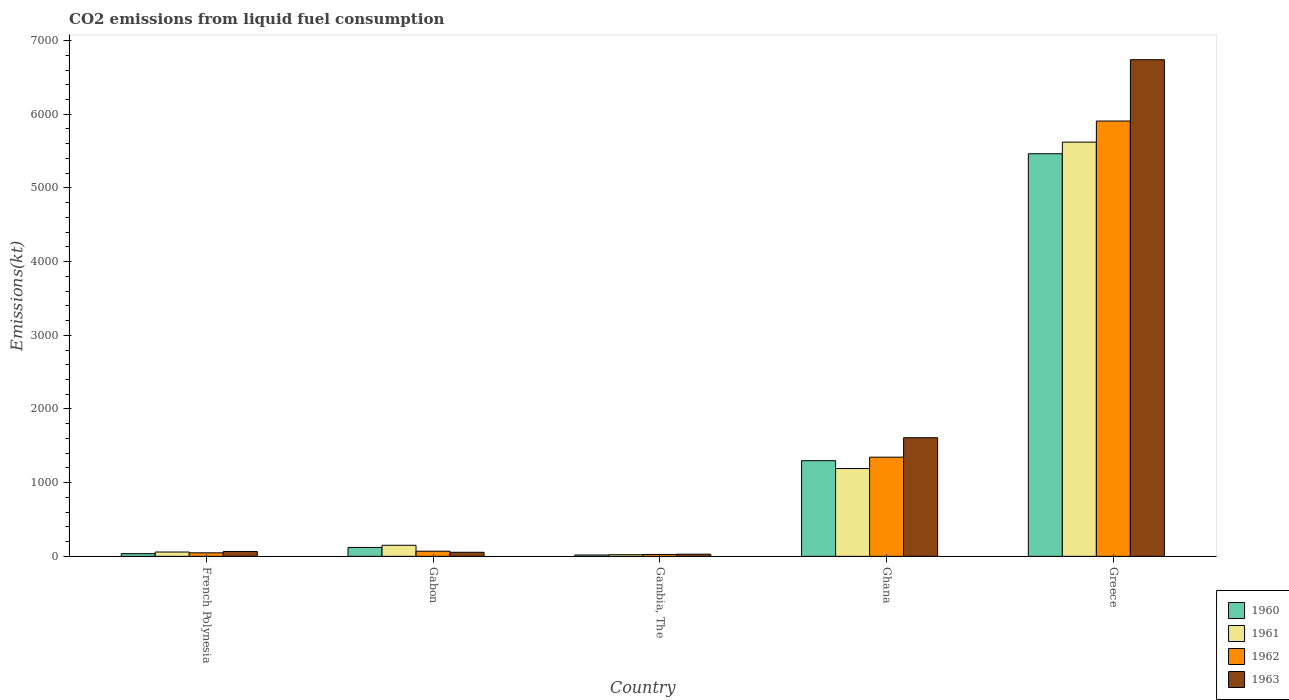How many different coloured bars are there?
Make the answer very short. 4. How many groups of bars are there?
Offer a very short reply. 5. Are the number of bars per tick equal to the number of legend labels?
Provide a short and direct response. Yes. Are the number of bars on each tick of the X-axis equal?
Provide a succinct answer. Yes. How many bars are there on the 3rd tick from the left?
Your response must be concise. 4. What is the label of the 1st group of bars from the left?
Give a very brief answer. French Polynesia. What is the amount of CO2 emitted in 1962 in Greece?
Ensure brevity in your answer.  5907.54. Across all countries, what is the maximum amount of CO2 emitted in 1962?
Offer a terse response. 5907.54. Across all countries, what is the minimum amount of CO2 emitted in 1960?
Keep it short and to the point. 18.34. In which country was the amount of CO2 emitted in 1961 minimum?
Your answer should be very brief. Gambia, The. What is the total amount of CO2 emitted in 1963 in the graph?
Offer a very short reply. 8500.11. What is the difference between the amount of CO2 emitted in 1961 in Gambia, The and that in Ghana?
Give a very brief answer. -1169.77. What is the difference between the amount of CO2 emitted in 1961 in Gabon and the amount of CO2 emitted in 1963 in Greece?
Offer a terse response. -6589.6. What is the average amount of CO2 emitted in 1960 per country?
Make the answer very short. 1387.59. What is the difference between the amount of CO2 emitted of/in 1963 and amount of CO2 emitted of/in 1961 in French Polynesia?
Keep it short and to the point. 7.33. What is the ratio of the amount of CO2 emitted in 1962 in French Polynesia to that in Gambia, The?
Provide a short and direct response. 1.86. Is the amount of CO2 emitted in 1961 in Gambia, The less than that in Ghana?
Your response must be concise. Yes. What is the difference between the highest and the second highest amount of CO2 emitted in 1960?
Ensure brevity in your answer.  -1177.11. What is the difference between the highest and the lowest amount of CO2 emitted in 1961?
Your response must be concise. 5599.51. What does the 3rd bar from the left in Gambia, The represents?
Offer a very short reply. 1962. How many countries are there in the graph?
Offer a very short reply. 5. Does the graph contain any zero values?
Provide a short and direct response. No. Where does the legend appear in the graph?
Keep it short and to the point. Bottom right. How are the legend labels stacked?
Keep it short and to the point. Vertical. What is the title of the graph?
Provide a short and direct response. CO2 emissions from liquid fuel consumption. Does "2011" appear as one of the legend labels in the graph?
Ensure brevity in your answer.  No. What is the label or title of the Y-axis?
Keep it short and to the point. Emissions(kt). What is the Emissions(kt) in 1960 in French Polynesia?
Offer a terse response. 36.67. What is the Emissions(kt) of 1961 in French Polynesia?
Provide a succinct answer. 58.67. What is the Emissions(kt) of 1962 in French Polynesia?
Your response must be concise. 47.67. What is the Emissions(kt) in 1963 in French Polynesia?
Your answer should be very brief. 66.01. What is the Emissions(kt) in 1960 in Gabon?
Give a very brief answer. 121.01. What is the Emissions(kt) of 1961 in Gabon?
Keep it short and to the point. 150.35. What is the Emissions(kt) of 1962 in Gabon?
Provide a succinct answer. 69.67. What is the Emissions(kt) in 1963 in Gabon?
Your answer should be compact. 55.01. What is the Emissions(kt) in 1960 in Gambia, The?
Ensure brevity in your answer.  18.34. What is the Emissions(kt) of 1961 in Gambia, The?
Your response must be concise. 22. What is the Emissions(kt) of 1962 in Gambia, The?
Give a very brief answer. 25.67. What is the Emissions(kt) in 1963 in Gambia, The?
Provide a short and direct response. 29.34. What is the Emissions(kt) in 1960 in Ghana?
Provide a succinct answer. 1298.12. What is the Emissions(kt) in 1961 in Ghana?
Keep it short and to the point. 1191.78. What is the Emissions(kt) of 1962 in Ghana?
Keep it short and to the point. 1345.79. What is the Emissions(kt) of 1963 in Ghana?
Your response must be concise. 1609.81. What is the Emissions(kt) in 1960 in Greece?
Ensure brevity in your answer.  5463.83. What is the Emissions(kt) in 1961 in Greece?
Your answer should be compact. 5621.51. What is the Emissions(kt) in 1962 in Greece?
Ensure brevity in your answer.  5907.54. What is the Emissions(kt) of 1963 in Greece?
Provide a succinct answer. 6739.95. Across all countries, what is the maximum Emissions(kt) in 1960?
Your response must be concise. 5463.83. Across all countries, what is the maximum Emissions(kt) of 1961?
Your answer should be very brief. 5621.51. Across all countries, what is the maximum Emissions(kt) of 1962?
Offer a very short reply. 5907.54. Across all countries, what is the maximum Emissions(kt) of 1963?
Provide a short and direct response. 6739.95. Across all countries, what is the minimum Emissions(kt) of 1960?
Provide a short and direct response. 18.34. Across all countries, what is the minimum Emissions(kt) of 1961?
Give a very brief answer. 22. Across all countries, what is the minimum Emissions(kt) of 1962?
Your response must be concise. 25.67. Across all countries, what is the minimum Emissions(kt) in 1963?
Ensure brevity in your answer.  29.34. What is the total Emissions(kt) in 1960 in the graph?
Your answer should be compact. 6937.96. What is the total Emissions(kt) in 1961 in the graph?
Provide a short and direct response. 7044.31. What is the total Emissions(kt) in 1962 in the graph?
Provide a short and direct response. 7396.34. What is the total Emissions(kt) of 1963 in the graph?
Keep it short and to the point. 8500.11. What is the difference between the Emissions(kt) of 1960 in French Polynesia and that in Gabon?
Make the answer very short. -84.34. What is the difference between the Emissions(kt) of 1961 in French Polynesia and that in Gabon?
Keep it short and to the point. -91.67. What is the difference between the Emissions(kt) of 1962 in French Polynesia and that in Gabon?
Offer a terse response. -22. What is the difference between the Emissions(kt) of 1963 in French Polynesia and that in Gabon?
Offer a very short reply. 11. What is the difference between the Emissions(kt) of 1960 in French Polynesia and that in Gambia, The?
Provide a short and direct response. 18.34. What is the difference between the Emissions(kt) in 1961 in French Polynesia and that in Gambia, The?
Make the answer very short. 36.67. What is the difference between the Emissions(kt) of 1962 in French Polynesia and that in Gambia, The?
Your response must be concise. 22. What is the difference between the Emissions(kt) in 1963 in French Polynesia and that in Gambia, The?
Keep it short and to the point. 36.67. What is the difference between the Emissions(kt) of 1960 in French Polynesia and that in Ghana?
Give a very brief answer. -1261.45. What is the difference between the Emissions(kt) in 1961 in French Polynesia and that in Ghana?
Provide a short and direct response. -1133.1. What is the difference between the Emissions(kt) in 1962 in French Polynesia and that in Ghana?
Your response must be concise. -1298.12. What is the difference between the Emissions(kt) in 1963 in French Polynesia and that in Ghana?
Provide a short and direct response. -1543.81. What is the difference between the Emissions(kt) of 1960 in French Polynesia and that in Greece?
Keep it short and to the point. -5427.16. What is the difference between the Emissions(kt) in 1961 in French Polynesia and that in Greece?
Make the answer very short. -5562.84. What is the difference between the Emissions(kt) of 1962 in French Polynesia and that in Greece?
Your answer should be compact. -5859.87. What is the difference between the Emissions(kt) of 1963 in French Polynesia and that in Greece?
Give a very brief answer. -6673.94. What is the difference between the Emissions(kt) of 1960 in Gabon and that in Gambia, The?
Provide a short and direct response. 102.68. What is the difference between the Emissions(kt) of 1961 in Gabon and that in Gambia, The?
Keep it short and to the point. 128.34. What is the difference between the Emissions(kt) of 1962 in Gabon and that in Gambia, The?
Ensure brevity in your answer.  44. What is the difference between the Emissions(kt) in 1963 in Gabon and that in Gambia, The?
Provide a succinct answer. 25.67. What is the difference between the Emissions(kt) of 1960 in Gabon and that in Ghana?
Offer a terse response. -1177.11. What is the difference between the Emissions(kt) of 1961 in Gabon and that in Ghana?
Keep it short and to the point. -1041.43. What is the difference between the Emissions(kt) of 1962 in Gabon and that in Ghana?
Provide a succinct answer. -1276.12. What is the difference between the Emissions(kt) of 1963 in Gabon and that in Ghana?
Offer a very short reply. -1554.81. What is the difference between the Emissions(kt) in 1960 in Gabon and that in Greece?
Offer a terse response. -5342.82. What is the difference between the Emissions(kt) of 1961 in Gabon and that in Greece?
Offer a very short reply. -5471.16. What is the difference between the Emissions(kt) of 1962 in Gabon and that in Greece?
Provide a succinct answer. -5837.86. What is the difference between the Emissions(kt) of 1963 in Gabon and that in Greece?
Ensure brevity in your answer.  -6684.94. What is the difference between the Emissions(kt) in 1960 in Gambia, The and that in Ghana?
Keep it short and to the point. -1279.78. What is the difference between the Emissions(kt) of 1961 in Gambia, The and that in Ghana?
Provide a short and direct response. -1169.77. What is the difference between the Emissions(kt) in 1962 in Gambia, The and that in Ghana?
Give a very brief answer. -1320.12. What is the difference between the Emissions(kt) of 1963 in Gambia, The and that in Ghana?
Offer a very short reply. -1580.48. What is the difference between the Emissions(kt) in 1960 in Gambia, The and that in Greece?
Your response must be concise. -5445.49. What is the difference between the Emissions(kt) of 1961 in Gambia, The and that in Greece?
Your answer should be compact. -5599.51. What is the difference between the Emissions(kt) of 1962 in Gambia, The and that in Greece?
Your answer should be very brief. -5881.87. What is the difference between the Emissions(kt) of 1963 in Gambia, The and that in Greece?
Offer a terse response. -6710.61. What is the difference between the Emissions(kt) of 1960 in Ghana and that in Greece?
Keep it short and to the point. -4165.71. What is the difference between the Emissions(kt) in 1961 in Ghana and that in Greece?
Your answer should be very brief. -4429.74. What is the difference between the Emissions(kt) of 1962 in Ghana and that in Greece?
Provide a succinct answer. -4561.75. What is the difference between the Emissions(kt) in 1963 in Ghana and that in Greece?
Provide a succinct answer. -5130.13. What is the difference between the Emissions(kt) in 1960 in French Polynesia and the Emissions(kt) in 1961 in Gabon?
Make the answer very short. -113.68. What is the difference between the Emissions(kt) in 1960 in French Polynesia and the Emissions(kt) in 1962 in Gabon?
Keep it short and to the point. -33. What is the difference between the Emissions(kt) of 1960 in French Polynesia and the Emissions(kt) of 1963 in Gabon?
Offer a very short reply. -18.34. What is the difference between the Emissions(kt) in 1961 in French Polynesia and the Emissions(kt) in 1962 in Gabon?
Give a very brief answer. -11. What is the difference between the Emissions(kt) of 1961 in French Polynesia and the Emissions(kt) of 1963 in Gabon?
Your response must be concise. 3.67. What is the difference between the Emissions(kt) in 1962 in French Polynesia and the Emissions(kt) in 1963 in Gabon?
Offer a terse response. -7.33. What is the difference between the Emissions(kt) of 1960 in French Polynesia and the Emissions(kt) of 1961 in Gambia, The?
Ensure brevity in your answer.  14.67. What is the difference between the Emissions(kt) in 1960 in French Polynesia and the Emissions(kt) in 1962 in Gambia, The?
Your response must be concise. 11. What is the difference between the Emissions(kt) of 1960 in French Polynesia and the Emissions(kt) of 1963 in Gambia, The?
Give a very brief answer. 7.33. What is the difference between the Emissions(kt) of 1961 in French Polynesia and the Emissions(kt) of 1962 in Gambia, The?
Keep it short and to the point. 33. What is the difference between the Emissions(kt) in 1961 in French Polynesia and the Emissions(kt) in 1963 in Gambia, The?
Keep it short and to the point. 29.34. What is the difference between the Emissions(kt) in 1962 in French Polynesia and the Emissions(kt) in 1963 in Gambia, The?
Ensure brevity in your answer.  18.34. What is the difference between the Emissions(kt) of 1960 in French Polynesia and the Emissions(kt) of 1961 in Ghana?
Give a very brief answer. -1155.11. What is the difference between the Emissions(kt) in 1960 in French Polynesia and the Emissions(kt) in 1962 in Ghana?
Your answer should be very brief. -1309.12. What is the difference between the Emissions(kt) of 1960 in French Polynesia and the Emissions(kt) of 1963 in Ghana?
Offer a very short reply. -1573.14. What is the difference between the Emissions(kt) in 1961 in French Polynesia and the Emissions(kt) in 1962 in Ghana?
Your response must be concise. -1287.12. What is the difference between the Emissions(kt) in 1961 in French Polynesia and the Emissions(kt) in 1963 in Ghana?
Offer a terse response. -1551.14. What is the difference between the Emissions(kt) of 1962 in French Polynesia and the Emissions(kt) of 1963 in Ghana?
Your answer should be very brief. -1562.14. What is the difference between the Emissions(kt) of 1960 in French Polynesia and the Emissions(kt) of 1961 in Greece?
Offer a terse response. -5584.84. What is the difference between the Emissions(kt) of 1960 in French Polynesia and the Emissions(kt) of 1962 in Greece?
Ensure brevity in your answer.  -5870.87. What is the difference between the Emissions(kt) in 1960 in French Polynesia and the Emissions(kt) in 1963 in Greece?
Make the answer very short. -6703.28. What is the difference between the Emissions(kt) of 1961 in French Polynesia and the Emissions(kt) of 1962 in Greece?
Provide a short and direct response. -5848.86. What is the difference between the Emissions(kt) in 1961 in French Polynesia and the Emissions(kt) in 1963 in Greece?
Keep it short and to the point. -6681.27. What is the difference between the Emissions(kt) in 1962 in French Polynesia and the Emissions(kt) in 1963 in Greece?
Make the answer very short. -6692.27. What is the difference between the Emissions(kt) in 1960 in Gabon and the Emissions(kt) in 1961 in Gambia, The?
Give a very brief answer. 99.01. What is the difference between the Emissions(kt) in 1960 in Gabon and the Emissions(kt) in 1962 in Gambia, The?
Your answer should be very brief. 95.34. What is the difference between the Emissions(kt) in 1960 in Gabon and the Emissions(kt) in 1963 in Gambia, The?
Your answer should be compact. 91.67. What is the difference between the Emissions(kt) in 1961 in Gabon and the Emissions(kt) in 1962 in Gambia, The?
Offer a terse response. 124.68. What is the difference between the Emissions(kt) in 1961 in Gabon and the Emissions(kt) in 1963 in Gambia, The?
Your answer should be very brief. 121.01. What is the difference between the Emissions(kt) of 1962 in Gabon and the Emissions(kt) of 1963 in Gambia, The?
Offer a very short reply. 40.34. What is the difference between the Emissions(kt) in 1960 in Gabon and the Emissions(kt) in 1961 in Ghana?
Offer a very short reply. -1070.76. What is the difference between the Emissions(kt) in 1960 in Gabon and the Emissions(kt) in 1962 in Ghana?
Offer a terse response. -1224.78. What is the difference between the Emissions(kt) in 1960 in Gabon and the Emissions(kt) in 1963 in Ghana?
Your answer should be compact. -1488.8. What is the difference between the Emissions(kt) of 1961 in Gabon and the Emissions(kt) of 1962 in Ghana?
Provide a succinct answer. -1195.44. What is the difference between the Emissions(kt) of 1961 in Gabon and the Emissions(kt) of 1963 in Ghana?
Make the answer very short. -1459.47. What is the difference between the Emissions(kt) in 1962 in Gabon and the Emissions(kt) in 1963 in Ghana?
Provide a short and direct response. -1540.14. What is the difference between the Emissions(kt) in 1960 in Gabon and the Emissions(kt) in 1961 in Greece?
Offer a terse response. -5500.5. What is the difference between the Emissions(kt) of 1960 in Gabon and the Emissions(kt) of 1962 in Greece?
Provide a succinct answer. -5786.53. What is the difference between the Emissions(kt) of 1960 in Gabon and the Emissions(kt) of 1963 in Greece?
Keep it short and to the point. -6618.94. What is the difference between the Emissions(kt) in 1961 in Gabon and the Emissions(kt) in 1962 in Greece?
Your answer should be very brief. -5757.19. What is the difference between the Emissions(kt) in 1961 in Gabon and the Emissions(kt) in 1963 in Greece?
Keep it short and to the point. -6589.6. What is the difference between the Emissions(kt) of 1962 in Gabon and the Emissions(kt) of 1963 in Greece?
Your response must be concise. -6670.27. What is the difference between the Emissions(kt) of 1960 in Gambia, The and the Emissions(kt) of 1961 in Ghana?
Give a very brief answer. -1173.44. What is the difference between the Emissions(kt) in 1960 in Gambia, The and the Emissions(kt) in 1962 in Ghana?
Offer a terse response. -1327.45. What is the difference between the Emissions(kt) of 1960 in Gambia, The and the Emissions(kt) of 1963 in Ghana?
Make the answer very short. -1591.48. What is the difference between the Emissions(kt) in 1961 in Gambia, The and the Emissions(kt) in 1962 in Ghana?
Give a very brief answer. -1323.79. What is the difference between the Emissions(kt) of 1961 in Gambia, The and the Emissions(kt) of 1963 in Ghana?
Provide a short and direct response. -1587.81. What is the difference between the Emissions(kt) of 1962 in Gambia, The and the Emissions(kt) of 1963 in Ghana?
Provide a succinct answer. -1584.14. What is the difference between the Emissions(kt) in 1960 in Gambia, The and the Emissions(kt) in 1961 in Greece?
Offer a terse response. -5603.18. What is the difference between the Emissions(kt) of 1960 in Gambia, The and the Emissions(kt) of 1962 in Greece?
Your answer should be very brief. -5889.2. What is the difference between the Emissions(kt) in 1960 in Gambia, The and the Emissions(kt) in 1963 in Greece?
Ensure brevity in your answer.  -6721.61. What is the difference between the Emissions(kt) in 1961 in Gambia, The and the Emissions(kt) in 1962 in Greece?
Your answer should be very brief. -5885.53. What is the difference between the Emissions(kt) of 1961 in Gambia, The and the Emissions(kt) of 1963 in Greece?
Provide a succinct answer. -6717.94. What is the difference between the Emissions(kt) of 1962 in Gambia, The and the Emissions(kt) of 1963 in Greece?
Keep it short and to the point. -6714.28. What is the difference between the Emissions(kt) in 1960 in Ghana and the Emissions(kt) in 1961 in Greece?
Provide a short and direct response. -4323.39. What is the difference between the Emissions(kt) in 1960 in Ghana and the Emissions(kt) in 1962 in Greece?
Your response must be concise. -4609.42. What is the difference between the Emissions(kt) of 1960 in Ghana and the Emissions(kt) of 1963 in Greece?
Provide a succinct answer. -5441.83. What is the difference between the Emissions(kt) in 1961 in Ghana and the Emissions(kt) in 1962 in Greece?
Provide a succinct answer. -4715.76. What is the difference between the Emissions(kt) of 1961 in Ghana and the Emissions(kt) of 1963 in Greece?
Offer a very short reply. -5548.17. What is the difference between the Emissions(kt) of 1962 in Ghana and the Emissions(kt) of 1963 in Greece?
Give a very brief answer. -5394.16. What is the average Emissions(kt) in 1960 per country?
Your response must be concise. 1387.59. What is the average Emissions(kt) in 1961 per country?
Keep it short and to the point. 1408.86. What is the average Emissions(kt) of 1962 per country?
Your answer should be compact. 1479.27. What is the average Emissions(kt) of 1963 per country?
Offer a very short reply. 1700.02. What is the difference between the Emissions(kt) in 1960 and Emissions(kt) in 1961 in French Polynesia?
Your response must be concise. -22. What is the difference between the Emissions(kt) in 1960 and Emissions(kt) in 1962 in French Polynesia?
Your response must be concise. -11. What is the difference between the Emissions(kt) in 1960 and Emissions(kt) in 1963 in French Polynesia?
Your answer should be very brief. -29.34. What is the difference between the Emissions(kt) in 1961 and Emissions(kt) in 1962 in French Polynesia?
Offer a very short reply. 11. What is the difference between the Emissions(kt) in 1961 and Emissions(kt) in 1963 in French Polynesia?
Give a very brief answer. -7.33. What is the difference between the Emissions(kt) of 1962 and Emissions(kt) of 1963 in French Polynesia?
Your response must be concise. -18.34. What is the difference between the Emissions(kt) of 1960 and Emissions(kt) of 1961 in Gabon?
Provide a succinct answer. -29.34. What is the difference between the Emissions(kt) in 1960 and Emissions(kt) in 1962 in Gabon?
Your answer should be very brief. 51.34. What is the difference between the Emissions(kt) of 1960 and Emissions(kt) of 1963 in Gabon?
Offer a terse response. 66.01. What is the difference between the Emissions(kt) of 1961 and Emissions(kt) of 1962 in Gabon?
Keep it short and to the point. 80.67. What is the difference between the Emissions(kt) of 1961 and Emissions(kt) of 1963 in Gabon?
Your answer should be very brief. 95.34. What is the difference between the Emissions(kt) in 1962 and Emissions(kt) in 1963 in Gabon?
Ensure brevity in your answer.  14.67. What is the difference between the Emissions(kt) of 1960 and Emissions(kt) of 1961 in Gambia, The?
Your response must be concise. -3.67. What is the difference between the Emissions(kt) in 1960 and Emissions(kt) in 1962 in Gambia, The?
Provide a succinct answer. -7.33. What is the difference between the Emissions(kt) in 1960 and Emissions(kt) in 1963 in Gambia, The?
Keep it short and to the point. -11. What is the difference between the Emissions(kt) in 1961 and Emissions(kt) in 1962 in Gambia, The?
Ensure brevity in your answer.  -3.67. What is the difference between the Emissions(kt) in 1961 and Emissions(kt) in 1963 in Gambia, The?
Offer a very short reply. -7.33. What is the difference between the Emissions(kt) of 1962 and Emissions(kt) of 1963 in Gambia, The?
Ensure brevity in your answer.  -3.67. What is the difference between the Emissions(kt) of 1960 and Emissions(kt) of 1961 in Ghana?
Offer a very short reply. 106.34. What is the difference between the Emissions(kt) in 1960 and Emissions(kt) in 1962 in Ghana?
Provide a succinct answer. -47.67. What is the difference between the Emissions(kt) of 1960 and Emissions(kt) of 1963 in Ghana?
Your response must be concise. -311.69. What is the difference between the Emissions(kt) of 1961 and Emissions(kt) of 1962 in Ghana?
Offer a very short reply. -154.01. What is the difference between the Emissions(kt) of 1961 and Emissions(kt) of 1963 in Ghana?
Your response must be concise. -418.04. What is the difference between the Emissions(kt) in 1962 and Emissions(kt) in 1963 in Ghana?
Ensure brevity in your answer.  -264.02. What is the difference between the Emissions(kt) in 1960 and Emissions(kt) in 1961 in Greece?
Ensure brevity in your answer.  -157.68. What is the difference between the Emissions(kt) in 1960 and Emissions(kt) in 1962 in Greece?
Give a very brief answer. -443.71. What is the difference between the Emissions(kt) in 1960 and Emissions(kt) in 1963 in Greece?
Make the answer very short. -1276.12. What is the difference between the Emissions(kt) of 1961 and Emissions(kt) of 1962 in Greece?
Make the answer very short. -286.03. What is the difference between the Emissions(kt) of 1961 and Emissions(kt) of 1963 in Greece?
Ensure brevity in your answer.  -1118.43. What is the difference between the Emissions(kt) in 1962 and Emissions(kt) in 1963 in Greece?
Give a very brief answer. -832.41. What is the ratio of the Emissions(kt) in 1960 in French Polynesia to that in Gabon?
Make the answer very short. 0.3. What is the ratio of the Emissions(kt) in 1961 in French Polynesia to that in Gabon?
Your answer should be compact. 0.39. What is the ratio of the Emissions(kt) in 1962 in French Polynesia to that in Gabon?
Provide a succinct answer. 0.68. What is the ratio of the Emissions(kt) in 1963 in French Polynesia to that in Gabon?
Offer a very short reply. 1.2. What is the ratio of the Emissions(kt) of 1960 in French Polynesia to that in Gambia, The?
Offer a very short reply. 2. What is the ratio of the Emissions(kt) in 1961 in French Polynesia to that in Gambia, The?
Offer a terse response. 2.67. What is the ratio of the Emissions(kt) of 1962 in French Polynesia to that in Gambia, The?
Your response must be concise. 1.86. What is the ratio of the Emissions(kt) in 1963 in French Polynesia to that in Gambia, The?
Your response must be concise. 2.25. What is the ratio of the Emissions(kt) in 1960 in French Polynesia to that in Ghana?
Offer a terse response. 0.03. What is the ratio of the Emissions(kt) of 1961 in French Polynesia to that in Ghana?
Your response must be concise. 0.05. What is the ratio of the Emissions(kt) in 1962 in French Polynesia to that in Ghana?
Make the answer very short. 0.04. What is the ratio of the Emissions(kt) in 1963 in French Polynesia to that in Ghana?
Provide a short and direct response. 0.04. What is the ratio of the Emissions(kt) of 1960 in French Polynesia to that in Greece?
Offer a very short reply. 0.01. What is the ratio of the Emissions(kt) of 1961 in French Polynesia to that in Greece?
Offer a terse response. 0.01. What is the ratio of the Emissions(kt) in 1962 in French Polynesia to that in Greece?
Provide a short and direct response. 0.01. What is the ratio of the Emissions(kt) in 1963 in French Polynesia to that in Greece?
Offer a terse response. 0.01. What is the ratio of the Emissions(kt) in 1961 in Gabon to that in Gambia, The?
Give a very brief answer. 6.83. What is the ratio of the Emissions(kt) in 1962 in Gabon to that in Gambia, The?
Provide a succinct answer. 2.71. What is the ratio of the Emissions(kt) of 1963 in Gabon to that in Gambia, The?
Your answer should be very brief. 1.88. What is the ratio of the Emissions(kt) in 1960 in Gabon to that in Ghana?
Provide a short and direct response. 0.09. What is the ratio of the Emissions(kt) of 1961 in Gabon to that in Ghana?
Your answer should be compact. 0.13. What is the ratio of the Emissions(kt) in 1962 in Gabon to that in Ghana?
Your answer should be compact. 0.05. What is the ratio of the Emissions(kt) in 1963 in Gabon to that in Ghana?
Ensure brevity in your answer.  0.03. What is the ratio of the Emissions(kt) in 1960 in Gabon to that in Greece?
Give a very brief answer. 0.02. What is the ratio of the Emissions(kt) of 1961 in Gabon to that in Greece?
Your answer should be very brief. 0.03. What is the ratio of the Emissions(kt) in 1962 in Gabon to that in Greece?
Your answer should be compact. 0.01. What is the ratio of the Emissions(kt) in 1963 in Gabon to that in Greece?
Provide a short and direct response. 0.01. What is the ratio of the Emissions(kt) of 1960 in Gambia, The to that in Ghana?
Give a very brief answer. 0.01. What is the ratio of the Emissions(kt) of 1961 in Gambia, The to that in Ghana?
Make the answer very short. 0.02. What is the ratio of the Emissions(kt) of 1962 in Gambia, The to that in Ghana?
Provide a succinct answer. 0.02. What is the ratio of the Emissions(kt) of 1963 in Gambia, The to that in Ghana?
Give a very brief answer. 0.02. What is the ratio of the Emissions(kt) of 1960 in Gambia, The to that in Greece?
Your answer should be very brief. 0. What is the ratio of the Emissions(kt) in 1961 in Gambia, The to that in Greece?
Your answer should be compact. 0. What is the ratio of the Emissions(kt) of 1962 in Gambia, The to that in Greece?
Offer a terse response. 0. What is the ratio of the Emissions(kt) of 1963 in Gambia, The to that in Greece?
Keep it short and to the point. 0. What is the ratio of the Emissions(kt) of 1960 in Ghana to that in Greece?
Provide a succinct answer. 0.24. What is the ratio of the Emissions(kt) of 1961 in Ghana to that in Greece?
Give a very brief answer. 0.21. What is the ratio of the Emissions(kt) of 1962 in Ghana to that in Greece?
Keep it short and to the point. 0.23. What is the ratio of the Emissions(kt) of 1963 in Ghana to that in Greece?
Provide a succinct answer. 0.24. What is the difference between the highest and the second highest Emissions(kt) in 1960?
Your answer should be compact. 4165.71. What is the difference between the highest and the second highest Emissions(kt) of 1961?
Your answer should be compact. 4429.74. What is the difference between the highest and the second highest Emissions(kt) of 1962?
Your response must be concise. 4561.75. What is the difference between the highest and the second highest Emissions(kt) in 1963?
Offer a very short reply. 5130.13. What is the difference between the highest and the lowest Emissions(kt) in 1960?
Offer a very short reply. 5445.49. What is the difference between the highest and the lowest Emissions(kt) in 1961?
Ensure brevity in your answer.  5599.51. What is the difference between the highest and the lowest Emissions(kt) of 1962?
Ensure brevity in your answer.  5881.87. What is the difference between the highest and the lowest Emissions(kt) in 1963?
Offer a very short reply. 6710.61. 